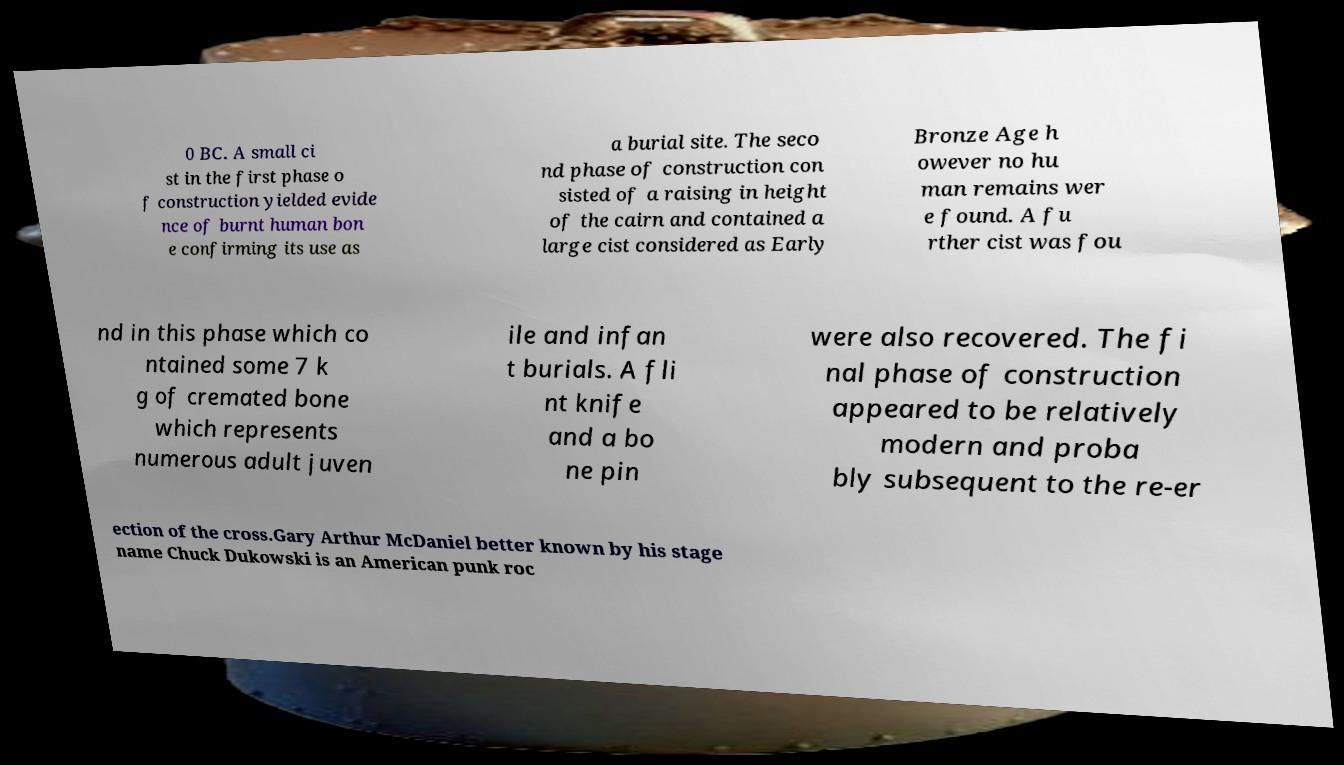Please identify and transcribe the text found in this image. 0 BC. A small ci st in the first phase o f construction yielded evide nce of burnt human bon e confirming its use as a burial site. The seco nd phase of construction con sisted of a raising in height of the cairn and contained a large cist considered as Early Bronze Age h owever no hu man remains wer e found. A fu rther cist was fou nd in this phase which co ntained some 7 k g of cremated bone which represents numerous adult juven ile and infan t burials. A fli nt knife and a bo ne pin were also recovered. The fi nal phase of construction appeared to be relatively modern and proba bly subsequent to the re-er ection of the cross.Gary Arthur McDaniel better known by his stage name Chuck Dukowski is an American punk roc 